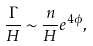Convert formula to latex. <formula><loc_0><loc_0><loc_500><loc_500>\frac { \Gamma } { H } \sim \frac { n } { H } e ^ { 4 \phi } ,</formula> 